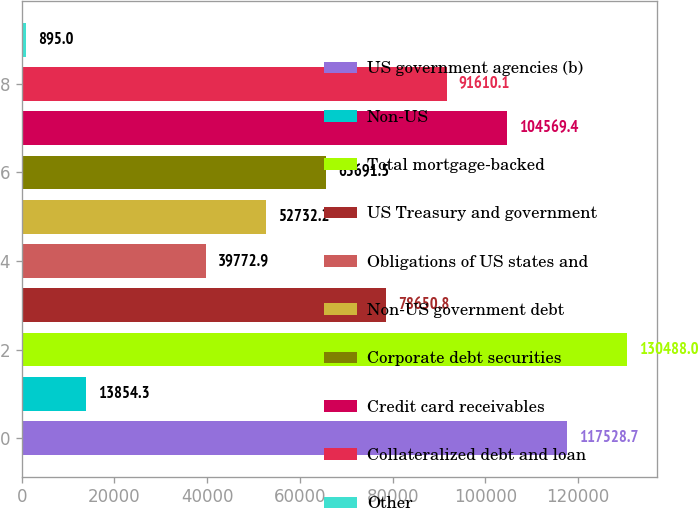Convert chart to OTSL. <chart><loc_0><loc_0><loc_500><loc_500><bar_chart><fcel>US government agencies (b)<fcel>Non-US<fcel>Total mortgage-backed<fcel>US Treasury and government<fcel>Obligations of US states and<fcel>Non-US government debt<fcel>Corporate debt securities<fcel>Credit card receivables<fcel>Collateralized debt and loan<fcel>Other<nl><fcel>117529<fcel>13854.3<fcel>130488<fcel>78650.8<fcel>39772.9<fcel>52732.2<fcel>65691.5<fcel>104569<fcel>91610.1<fcel>895<nl></chart> 